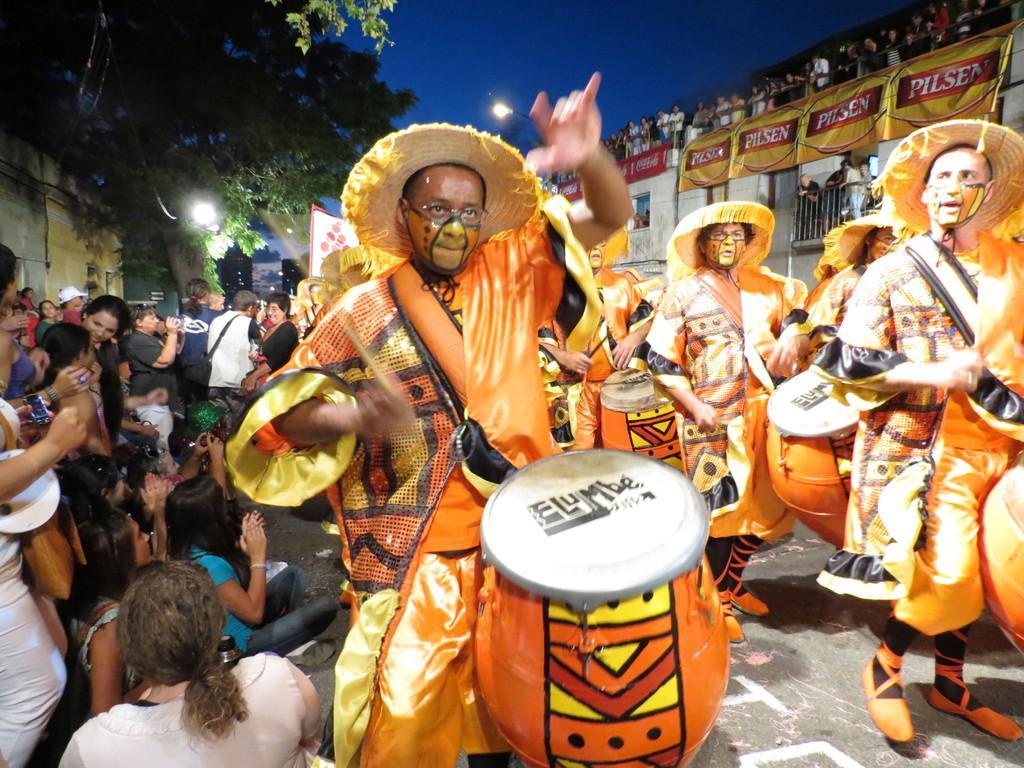Describe this image in one or two sentences. These group of people are playing musical drums. Above this building there are many persons standing. These are trees and lights. These are group of people. 